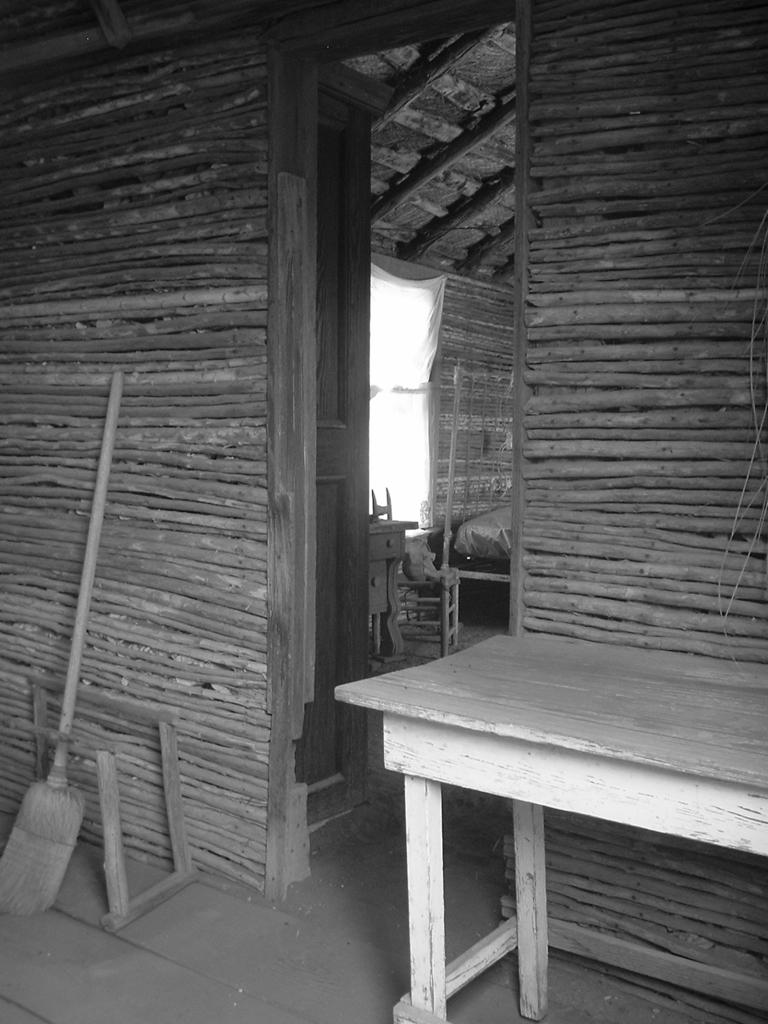What is the color scheme of the image? The image is black and white. What type of structure can be seen in the background? There is a wooden home in the background. What furniture or object is present in the image? There is a table in the image. What is the broomstick's position in relation to the wooden home? The broomstick is in front of the wooden home. What type of ornament is hanging from the broomstick in the image? There is no ornament hanging from the broomstick in the image. Can you tell me how many whips are visible in the image? There are no whips present in the image. 